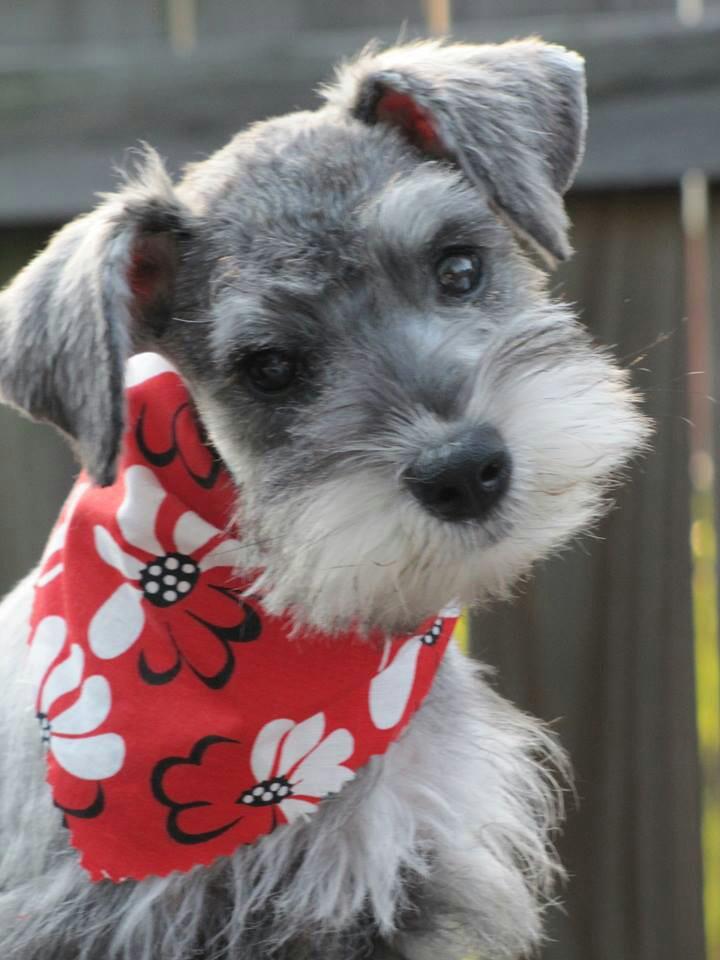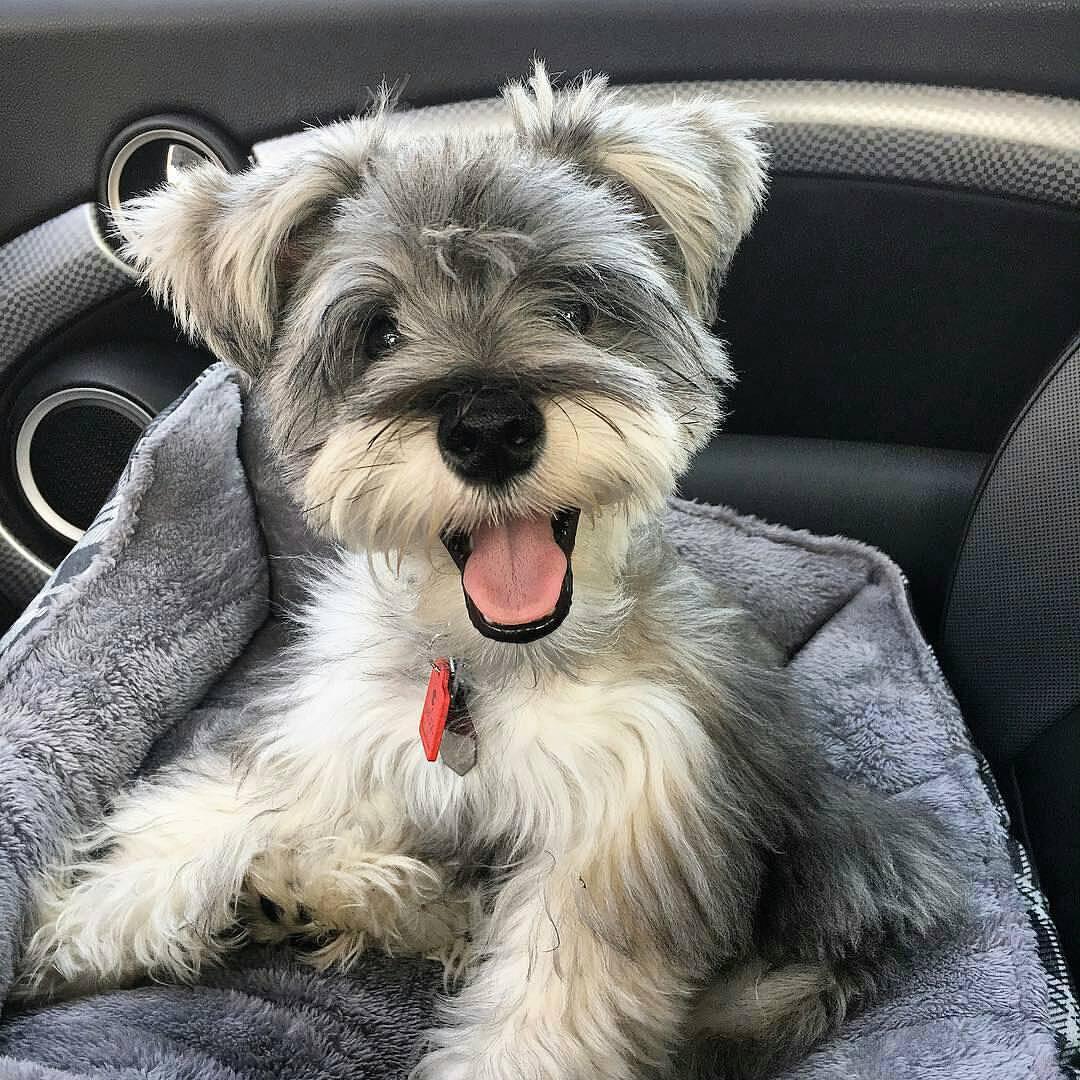The first image is the image on the left, the second image is the image on the right. Considering the images on both sides, is "An image shows one schnauzer, which is wearing a printed bandana around its neck." valid? Answer yes or no. Yes. 